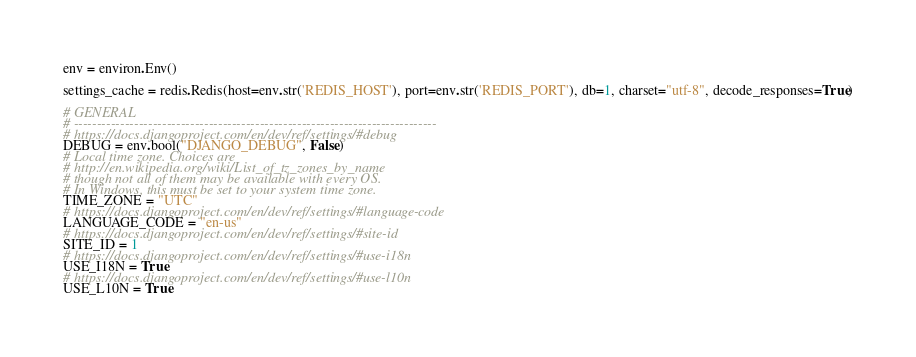<code> <loc_0><loc_0><loc_500><loc_500><_Python_>
env = environ.Env()

settings_cache = redis.Redis(host=env.str('REDIS_HOST'), port=env.str('REDIS_PORT'), db=1, charset="utf-8", decode_responses=True)

# GENERAL
# ------------------------------------------------------------------------------
# https://docs.djangoproject.com/en/dev/ref/settings/#debug
DEBUG = env.bool("DJANGO_DEBUG", False)
# Local time zone. Choices are
# http://en.wikipedia.org/wiki/List_of_tz_zones_by_name
# though not all of them may be available with every OS.
# In Windows, this must be set to your system time zone.
TIME_ZONE = "UTC"
# https://docs.djangoproject.com/en/dev/ref/settings/#language-code
LANGUAGE_CODE = "en-us"
# https://docs.djangoproject.com/en/dev/ref/settings/#site-id
SITE_ID = 1
# https://docs.djangoproject.com/en/dev/ref/settings/#use-i18n
USE_I18N = True
# https://docs.djangoproject.com/en/dev/ref/settings/#use-l10n
USE_L10N = True</code> 